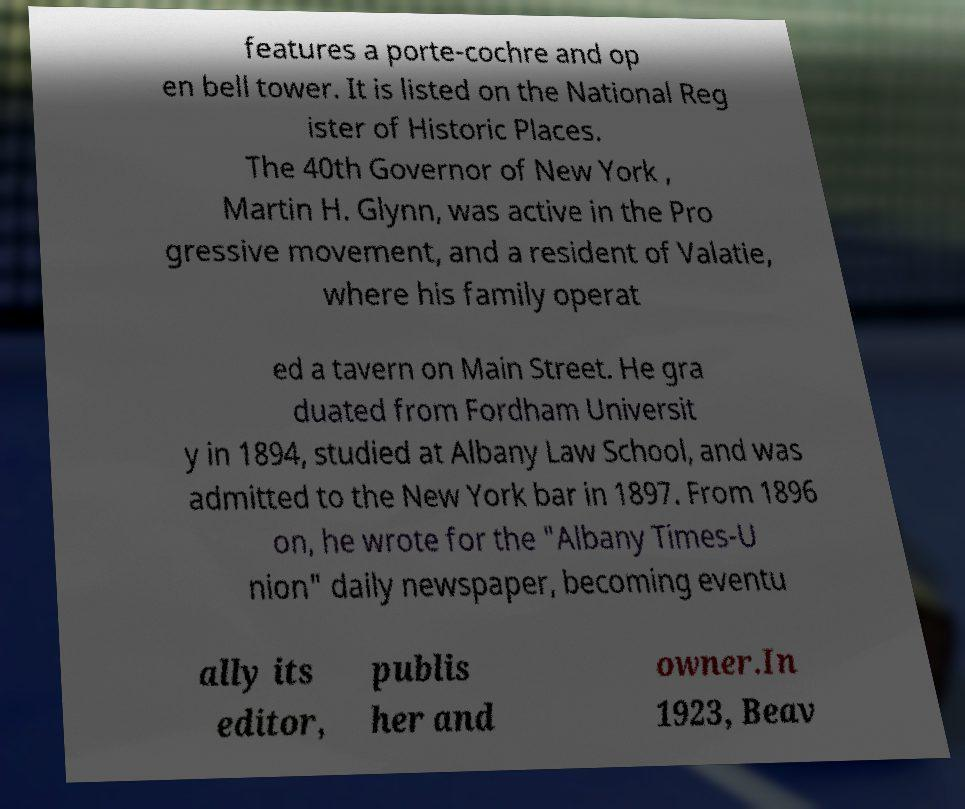Could you assist in decoding the text presented in this image and type it out clearly? features a porte-cochre and op en bell tower. It is listed on the National Reg ister of Historic Places. The 40th Governor of New York , Martin H. Glynn, was active in the Pro gressive movement, and a resident of Valatie, where his family operat ed a tavern on Main Street. He gra duated from Fordham Universit y in 1894, studied at Albany Law School, and was admitted to the New York bar in 1897. From 1896 on, he wrote for the "Albany Times-U nion" daily newspaper, becoming eventu ally its editor, publis her and owner.In 1923, Beav 